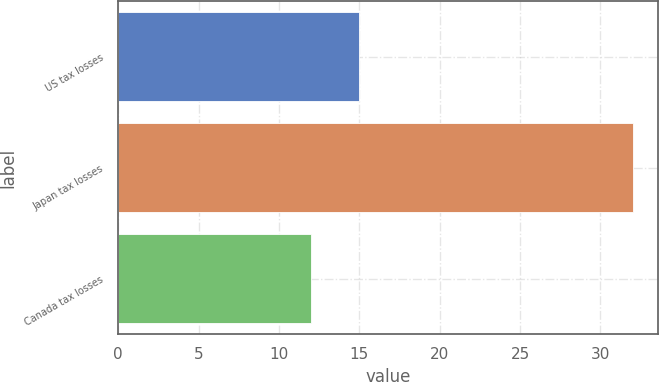Convert chart to OTSL. <chart><loc_0><loc_0><loc_500><loc_500><bar_chart><fcel>US tax losses<fcel>Japan tax losses<fcel>Canada tax losses<nl><fcel>15<fcel>32<fcel>12<nl></chart> 